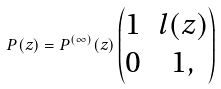Convert formula to latex. <formula><loc_0><loc_0><loc_500><loc_500>P ( z ) = P ^ { ( \infty ) } ( z ) \begin{pmatrix} 1 & l ( z ) \\ 0 & 1 , \end{pmatrix}</formula> 